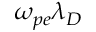<formula> <loc_0><loc_0><loc_500><loc_500>\omega _ { p e } \lambda _ { D }</formula> 